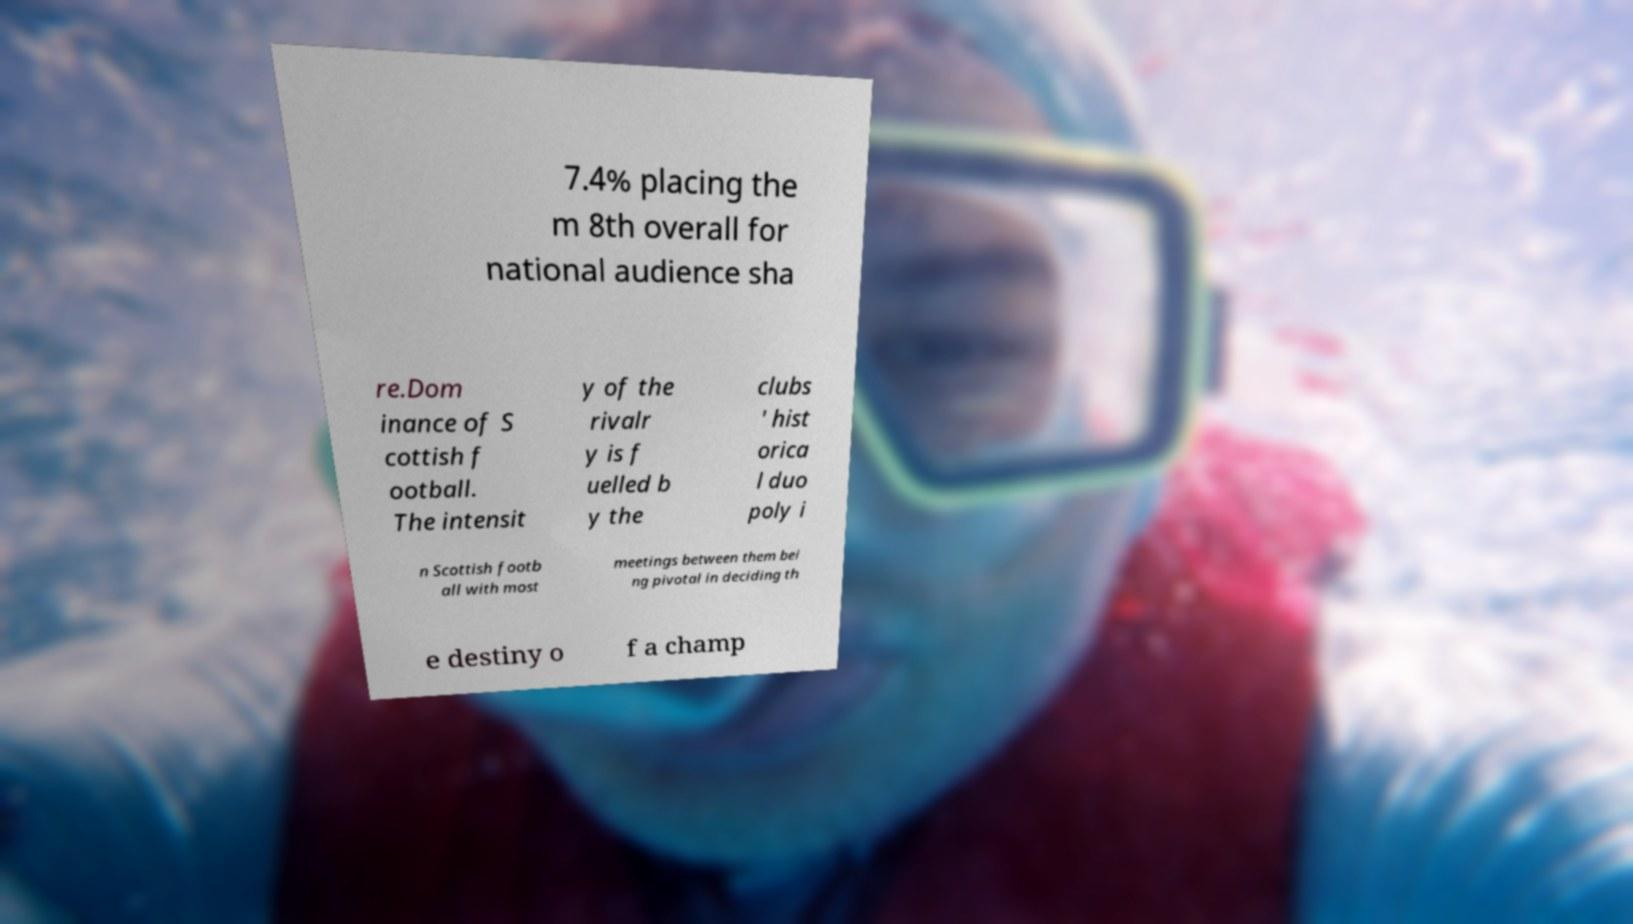Could you assist in decoding the text presented in this image and type it out clearly? 7.4% placing the m 8th overall for national audience sha re.Dom inance of S cottish f ootball. The intensit y of the rivalr y is f uelled b y the clubs ' hist orica l duo poly i n Scottish footb all with most meetings between them bei ng pivotal in deciding th e destiny o f a champ 